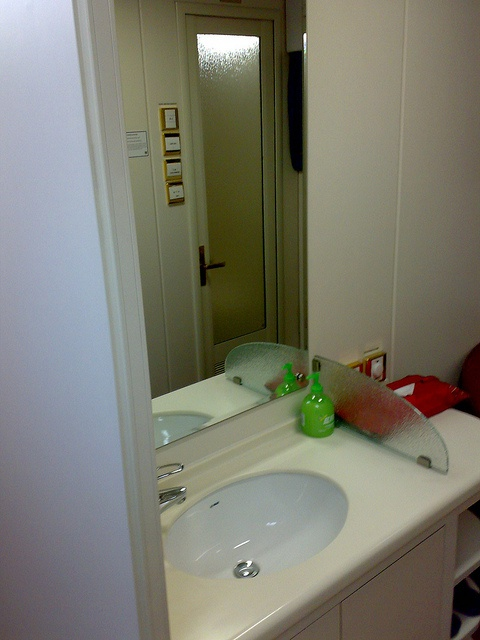Describe the objects in this image and their specific colors. I can see sink in lavender, darkgray, and gray tones and bottle in lavender, darkgreen, and green tones in this image. 